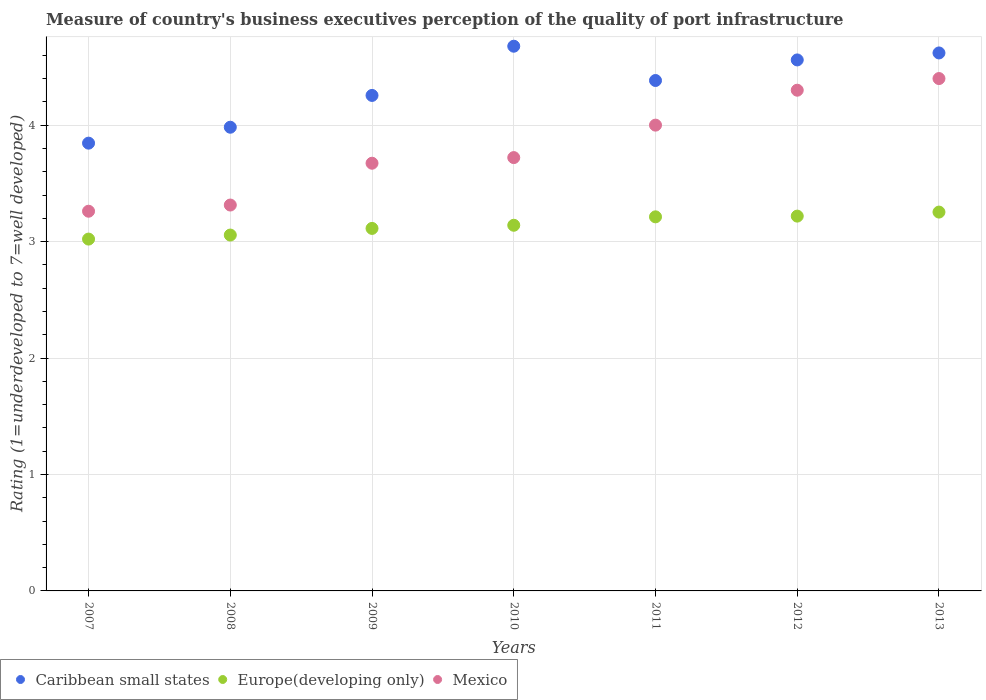Is the number of dotlines equal to the number of legend labels?
Offer a very short reply. Yes. What is the ratings of the quality of port infrastructure in Mexico in 2010?
Your response must be concise. 3.72. Across all years, what is the maximum ratings of the quality of port infrastructure in Europe(developing only)?
Your answer should be compact. 3.25. Across all years, what is the minimum ratings of the quality of port infrastructure in Mexico?
Your answer should be very brief. 3.26. In which year was the ratings of the quality of port infrastructure in Caribbean small states minimum?
Your answer should be compact. 2007. What is the total ratings of the quality of port infrastructure in Europe(developing only) in the graph?
Ensure brevity in your answer.  22.02. What is the difference between the ratings of the quality of port infrastructure in Europe(developing only) in 2007 and that in 2012?
Offer a very short reply. -0.2. What is the difference between the ratings of the quality of port infrastructure in Caribbean small states in 2008 and the ratings of the quality of port infrastructure in Europe(developing only) in 2007?
Provide a succinct answer. 0.96. What is the average ratings of the quality of port infrastructure in Mexico per year?
Offer a terse response. 3.81. In the year 2007, what is the difference between the ratings of the quality of port infrastructure in Caribbean small states and ratings of the quality of port infrastructure in Europe(developing only)?
Your answer should be compact. 0.82. In how many years, is the ratings of the quality of port infrastructure in Caribbean small states greater than 3.6?
Provide a short and direct response. 7. What is the ratio of the ratings of the quality of port infrastructure in Caribbean small states in 2011 to that in 2013?
Offer a very short reply. 0.95. What is the difference between the highest and the second highest ratings of the quality of port infrastructure in Mexico?
Offer a very short reply. 0.1. What is the difference between the highest and the lowest ratings of the quality of port infrastructure in Mexico?
Provide a succinct answer. 1.14. Does the ratings of the quality of port infrastructure in Mexico monotonically increase over the years?
Your answer should be compact. Yes. Are the values on the major ticks of Y-axis written in scientific E-notation?
Ensure brevity in your answer.  No. Does the graph contain any zero values?
Give a very brief answer. No. How are the legend labels stacked?
Give a very brief answer. Horizontal. What is the title of the graph?
Ensure brevity in your answer.  Measure of country's business executives perception of the quality of port infrastructure. What is the label or title of the X-axis?
Provide a short and direct response. Years. What is the label or title of the Y-axis?
Your answer should be compact. Rating (1=underdeveloped to 7=well developed). What is the Rating (1=underdeveloped to 7=well developed) in Caribbean small states in 2007?
Provide a succinct answer. 3.85. What is the Rating (1=underdeveloped to 7=well developed) in Europe(developing only) in 2007?
Provide a succinct answer. 3.02. What is the Rating (1=underdeveloped to 7=well developed) in Mexico in 2007?
Provide a succinct answer. 3.26. What is the Rating (1=underdeveloped to 7=well developed) in Caribbean small states in 2008?
Your response must be concise. 3.98. What is the Rating (1=underdeveloped to 7=well developed) in Europe(developing only) in 2008?
Your response must be concise. 3.06. What is the Rating (1=underdeveloped to 7=well developed) in Mexico in 2008?
Your answer should be very brief. 3.31. What is the Rating (1=underdeveloped to 7=well developed) in Caribbean small states in 2009?
Give a very brief answer. 4.26. What is the Rating (1=underdeveloped to 7=well developed) of Europe(developing only) in 2009?
Give a very brief answer. 3.11. What is the Rating (1=underdeveloped to 7=well developed) in Mexico in 2009?
Ensure brevity in your answer.  3.67. What is the Rating (1=underdeveloped to 7=well developed) of Caribbean small states in 2010?
Offer a very short reply. 4.68. What is the Rating (1=underdeveloped to 7=well developed) of Europe(developing only) in 2010?
Offer a terse response. 3.14. What is the Rating (1=underdeveloped to 7=well developed) of Mexico in 2010?
Provide a succinct answer. 3.72. What is the Rating (1=underdeveloped to 7=well developed) of Caribbean small states in 2011?
Ensure brevity in your answer.  4.38. What is the Rating (1=underdeveloped to 7=well developed) of Europe(developing only) in 2011?
Provide a succinct answer. 3.21. What is the Rating (1=underdeveloped to 7=well developed) in Mexico in 2011?
Ensure brevity in your answer.  4. What is the Rating (1=underdeveloped to 7=well developed) in Caribbean small states in 2012?
Give a very brief answer. 4.56. What is the Rating (1=underdeveloped to 7=well developed) in Europe(developing only) in 2012?
Offer a terse response. 3.22. What is the Rating (1=underdeveloped to 7=well developed) of Mexico in 2012?
Offer a very short reply. 4.3. What is the Rating (1=underdeveloped to 7=well developed) of Caribbean small states in 2013?
Offer a terse response. 4.62. What is the Rating (1=underdeveloped to 7=well developed) in Europe(developing only) in 2013?
Make the answer very short. 3.25. Across all years, what is the maximum Rating (1=underdeveloped to 7=well developed) in Caribbean small states?
Your response must be concise. 4.68. Across all years, what is the maximum Rating (1=underdeveloped to 7=well developed) in Europe(developing only)?
Offer a terse response. 3.25. Across all years, what is the maximum Rating (1=underdeveloped to 7=well developed) in Mexico?
Ensure brevity in your answer.  4.4. Across all years, what is the minimum Rating (1=underdeveloped to 7=well developed) in Caribbean small states?
Offer a terse response. 3.85. Across all years, what is the minimum Rating (1=underdeveloped to 7=well developed) of Europe(developing only)?
Your response must be concise. 3.02. Across all years, what is the minimum Rating (1=underdeveloped to 7=well developed) of Mexico?
Make the answer very short. 3.26. What is the total Rating (1=underdeveloped to 7=well developed) in Caribbean small states in the graph?
Your answer should be very brief. 30.32. What is the total Rating (1=underdeveloped to 7=well developed) in Europe(developing only) in the graph?
Your answer should be very brief. 22.02. What is the total Rating (1=underdeveloped to 7=well developed) in Mexico in the graph?
Your response must be concise. 26.67. What is the difference between the Rating (1=underdeveloped to 7=well developed) in Caribbean small states in 2007 and that in 2008?
Your response must be concise. -0.14. What is the difference between the Rating (1=underdeveloped to 7=well developed) in Europe(developing only) in 2007 and that in 2008?
Your answer should be compact. -0.03. What is the difference between the Rating (1=underdeveloped to 7=well developed) in Mexico in 2007 and that in 2008?
Keep it short and to the point. -0.05. What is the difference between the Rating (1=underdeveloped to 7=well developed) of Caribbean small states in 2007 and that in 2009?
Your answer should be very brief. -0.41. What is the difference between the Rating (1=underdeveloped to 7=well developed) in Europe(developing only) in 2007 and that in 2009?
Your answer should be very brief. -0.09. What is the difference between the Rating (1=underdeveloped to 7=well developed) of Mexico in 2007 and that in 2009?
Your answer should be compact. -0.41. What is the difference between the Rating (1=underdeveloped to 7=well developed) of Caribbean small states in 2007 and that in 2010?
Offer a terse response. -0.83. What is the difference between the Rating (1=underdeveloped to 7=well developed) of Europe(developing only) in 2007 and that in 2010?
Provide a succinct answer. -0.12. What is the difference between the Rating (1=underdeveloped to 7=well developed) of Mexico in 2007 and that in 2010?
Give a very brief answer. -0.46. What is the difference between the Rating (1=underdeveloped to 7=well developed) of Caribbean small states in 2007 and that in 2011?
Your answer should be compact. -0.54. What is the difference between the Rating (1=underdeveloped to 7=well developed) in Europe(developing only) in 2007 and that in 2011?
Provide a succinct answer. -0.19. What is the difference between the Rating (1=underdeveloped to 7=well developed) of Mexico in 2007 and that in 2011?
Make the answer very short. -0.74. What is the difference between the Rating (1=underdeveloped to 7=well developed) in Caribbean small states in 2007 and that in 2012?
Offer a very short reply. -0.71. What is the difference between the Rating (1=underdeveloped to 7=well developed) in Europe(developing only) in 2007 and that in 2012?
Give a very brief answer. -0.2. What is the difference between the Rating (1=underdeveloped to 7=well developed) in Mexico in 2007 and that in 2012?
Your answer should be compact. -1.04. What is the difference between the Rating (1=underdeveloped to 7=well developed) of Caribbean small states in 2007 and that in 2013?
Keep it short and to the point. -0.77. What is the difference between the Rating (1=underdeveloped to 7=well developed) of Europe(developing only) in 2007 and that in 2013?
Provide a succinct answer. -0.23. What is the difference between the Rating (1=underdeveloped to 7=well developed) of Mexico in 2007 and that in 2013?
Ensure brevity in your answer.  -1.14. What is the difference between the Rating (1=underdeveloped to 7=well developed) of Caribbean small states in 2008 and that in 2009?
Your response must be concise. -0.27. What is the difference between the Rating (1=underdeveloped to 7=well developed) in Europe(developing only) in 2008 and that in 2009?
Offer a terse response. -0.06. What is the difference between the Rating (1=underdeveloped to 7=well developed) of Mexico in 2008 and that in 2009?
Your response must be concise. -0.36. What is the difference between the Rating (1=underdeveloped to 7=well developed) in Caribbean small states in 2008 and that in 2010?
Provide a succinct answer. -0.7. What is the difference between the Rating (1=underdeveloped to 7=well developed) of Europe(developing only) in 2008 and that in 2010?
Provide a short and direct response. -0.08. What is the difference between the Rating (1=underdeveloped to 7=well developed) of Mexico in 2008 and that in 2010?
Ensure brevity in your answer.  -0.41. What is the difference between the Rating (1=underdeveloped to 7=well developed) of Caribbean small states in 2008 and that in 2011?
Give a very brief answer. -0.4. What is the difference between the Rating (1=underdeveloped to 7=well developed) of Europe(developing only) in 2008 and that in 2011?
Your answer should be compact. -0.16. What is the difference between the Rating (1=underdeveloped to 7=well developed) in Mexico in 2008 and that in 2011?
Your answer should be very brief. -0.69. What is the difference between the Rating (1=underdeveloped to 7=well developed) in Caribbean small states in 2008 and that in 2012?
Provide a succinct answer. -0.58. What is the difference between the Rating (1=underdeveloped to 7=well developed) in Europe(developing only) in 2008 and that in 2012?
Your response must be concise. -0.16. What is the difference between the Rating (1=underdeveloped to 7=well developed) of Mexico in 2008 and that in 2012?
Provide a short and direct response. -0.99. What is the difference between the Rating (1=underdeveloped to 7=well developed) in Caribbean small states in 2008 and that in 2013?
Provide a succinct answer. -0.64. What is the difference between the Rating (1=underdeveloped to 7=well developed) in Europe(developing only) in 2008 and that in 2013?
Your answer should be compact. -0.2. What is the difference between the Rating (1=underdeveloped to 7=well developed) of Mexico in 2008 and that in 2013?
Offer a very short reply. -1.09. What is the difference between the Rating (1=underdeveloped to 7=well developed) in Caribbean small states in 2009 and that in 2010?
Give a very brief answer. -0.42. What is the difference between the Rating (1=underdeveloped to 7=well developed) in Europe(developing only) in 2009 and that in 2010?
Offer a very short reply. -0.03. What is the difference between the Rating (1=underdeveloped to 7=well developed) of Mexico in 2009 and that in 2010?
Offer a very short reply. -0.05. What is the difference between the Rating (1=underdeveloped to 7=well developed) of Caribbean small states in 2009 and that in 2011?
Your answer should be very brief. -0.13. What is the difference between the Rating (1=underdeveloped to 7=well developed) of Europe(developing only) in 2009 and that in 2011?
Make the answer very short. -0.1. What is the difference between the Rating (1=underdeveloped to 7=well developed) in Mexico in 2009 and that in 2011?
Your answer should be compact. -0.33. What is the difference between the Rating (1=underdeveloped to 7=well developed) in Caribbean small states in 2009 and that in 2012?
Ensure brevity in your answer.  -0.3. What is the difference between the Rating (1=underdeveloped to 7=well developed) in Europe(developing only) in 2009 and that in 2012?
Keep it short and to the point. -0.11. What is the difference between the Rating (1=underdeveloped to 7=well developed) of Mexico in 2009 and that in 2012?
Ensure brevity in your answer.  -0.63. What is the difference between the Rating (1=underdeveloped to 7=well developed) in Caribbean small states in 2009 and that in 2013?
Offer a terse response. -0.36. What is the difference between the Rating (1=underdeveloped to 7=well developed) of Europe(developing only) in 2009 and that in 2013?
Ensure brevity in your answer.  -0.14. What is the difference between the Rating (1=underdeveloped to 7=well developed) of Mexico in 2009 and that in 2013?
Keep it short and to the point. -0.73. What is the difference between the Rating (1=underdeveloped to 7=well developed) of Caribbean small states in 2010 and that in 2011?
Your answer should be very brief. 0.29. What is the difference between the Rating (1=underdeveloped to 7=well developed) in Europe(developing only) in 2010 and that in 2011?
Make the answer very short. -0.07. What is the difference between the Rating (1=underdeveloped to 7=well developed) of Mexico in 2010 and that in 2011?
Offer a terse response. -0.28. What is the difference between the Rating (1=underdeveloped to 7=well developed) in Caribbean small states in 2010 and that in 2012?
Offer a terse response. 0.12. What is the difference between the Rating (1=underdeveloped to 7=well developed) of Europe(developing only) in 2010 and that in 2012?
Your answer should be very brief. -0.08. What is the difference between the Rating (1=underdeveloped to 7=well developed) in Mexico in 2010 and that in 2012?
Keep it short and to the point. -0.58. What is the difference between the Rating (1=underdeveloped to 7=well developed) of Caribbean small states in 2010 and that in 2013?
Your answer should be compact. 0.06. What is the difference between the Rating (1=underdeveloped to 7=well developed) in Europe(developing only) in 2010 and that in 2013?
Your answer should be very brief. -0.11. What is the difference between the Rating (1=underdeveloped to 7=well developed) in Mexico in 2010 and that in 2013?
Your answer should be compact. -0.68. What is the difference between the Rating (1=underdeveloped to 7=well developed) of Caribbean small states in 2011 and that in 2012?
Your answer should be compact. -0.18. What is the difference between the Rating (1=underdeveloped to 7=well developed) of Europe(developing only) in 2011 and that in 2012?
Give a very brief answer. -0.01. What is the difference between the Rating (1=underdeveloped to 7=well developed) of Mexico in 2011 and that in 2012?
Ensure brevity in your answer.  -0.3. What is the difference between the Rating (1=underdeveloped to 7=well developed) in Caribbean small states in 2011 and that in 2013?
Provide a short and direct response. -0.24. What is the difference between the Rating (1=underdeveloped to 7=well developed) in Europe(developing only) in 2011 and that in 2013?
Provide a succinct answer. -0.04. What is the difference between the Rating (1=underdeveloped to 7=well developed) in Caribbean small states in 2012 and that in 2013?
Ensure brevity in your answer.  -0.06. What is the difference between the Rating (1=underdeveloped to 7=well developed) of Europe(developing only) in 2012 and that in 2013?
Your answer should be very brief. -0.03. What is the difference between the Rating (1=underdeveloped to 7=well developed) of Caribbean small states in 2007 and the Rating (1=underdeveloped to 7=well developed) of Europe(developing only) in 2008?
Ensure brevity in your answer.  0.79. What is the difference between the Rating (1=underdeveloped to 7=well developed) in Caribbean small states in 2007 and the Rating (1=underdeveloped to 7=well developed) in Mexico in 2008?
Ensure brevity in your answer.  0.53. What is the difference between the Rating (1=underdeveloped to 7=well developed) of Europe(developing only) in 2007 and the Rating (1=underdeveloped to 7=well developed) of Mexico in 2008?
Provide a short and direct response. -0.29. What is the difference between the Rating (1=underdeveloped to 7=well developed) of Caribbean small states in 2007 and the Rating (1=underdeveloped to 7=well developed) of Europe(developing only) in 2009?
Keep it short and to the point. 0.73. What is the difference between the Rating (1=underdeveloped to 7=well developed) in Caribbean small states in 2007 and the Rating (1=underdeveloped to 7=well developed) in Mexico in 2009?
Keep it short and to the point. 0.17. What is the difference between the Rating (1=underdeveloped to 7=well developed) of Europe(developing only) in 2007 and the Rating (1=underdeveloped to 7=well developed) of Mexico in 2009?
Your response must be concise. -0.65. What is the difference between the Rating (1=underdeveloped to 7=well developed) of Caribbean small states in 2007 and the Rating (1=underdeveloped to 7=well developed) of Europe(developing only) in 2010?
Make the answer very short. 0.71. What is the difference between the Rating (1=underdeveloped to 7=well developed) of Caribbean small states in 2007 and the Rating (1=underdeveloped to 7=well developed) of Mexico in 2010?
Provide a short and direct response. 0.12. What is the difference between the Rating (1=underdeveloped to 7=well developed) in Europe(developing only) in 2007 and the Rating (1=underdeveloped to 7=well developed) in Mexico in 2010?
Offer a very short reply. -0.7. What is the difference between the Rating (1=underdeveloped to 7=well developed) of Caribbean small states in 2007 and the Rating (1=underdeveloped to 7=well developed) of Europe(developing only) in 2011?
Provide a succinct answer. 0.63. What is the difference between the Rating (1=underdeveloped to 7=well developed) in Caribbean small states in 2007 and the Rating (1=underdeveloped to 7=well developed) in Mexico in 2011?
Offer a very short reply. -0.15. What is the difference between the Rating (1=underdeveloped to 7=well developed) in Europe(developing only) in 2007 and the Rating (1=underdeveloped to 7=well developed) in Mexico in 2011?
Your response must be concise. -0.98. What is the difference between the Rating (1=underdeveloped to 7=well developed) in Caribbean small states in 2007 and the Rating (1=underdeveloped to 7=well developed) in Europe(developing only) in 2012?
Provide a succinct answer. 0.63. What is the difference between the Rating (1=underdeveloped to 7=well developed) in Caribbean small states in 2007 and the Rating (1=underdeveloped to 7=well developed) in Mexico in 2012?
Ensure brevity in your answer.  -0.45. What is the difference between the Rating (1=underdeveloped to 7=well developed) in Europe(developing only) in 2007 and the Rating (1=underdeveloped to 7=well developed) in Mexico in 2012?
Offer a very short reply. -1.28. What is the difference between the Rating (1=underdeveloped to 7=well developed) of Caribbean small states in 2007 and the Rating (1=underdeveloped to 7=well developed) of Europe(developing only) in 2013?
Provide a succinct answer. 0.59. What is the difference between the Rating (1=underdeveloped to 7=well developed) of Caribbean small states in 2007 and the Rating (1=underdeveloped to 7=well developed) of Mexico in 2013?
Keep it short and to the point. -0.55. What is the difference between the Rating (1=underdeveloped to 7=well developed) of Europe(developing only) in 2007 and the Rating (1=underdeveloped to 7=well developed) of Mexico in 2013?
Give a very brief answer. -1.38. What is the difference between the Rating (1=underdeveloped to 7=well developed) of Caribbean small states in 2008 and the Rating (1=underdeveloped to 7=well developed) of Europe(developing only) in 2009?
Make the answer very short. 0.87. What is the difference between the Rating (1=underdeveloped to 7=well developed) of Caribbean small states in 2008 and the Rating (1=underdeveloped to 7=well developed) of Mexico in 2009?
Provide a short and direct response. 0.31. What is the difference between the Rating (1=underdeveloped to 7=well developed) of Europe(developing only) in 2008 and the Rating (1=underdeveloped to 7=well developed) of Mexico in 2009?
Your answer should be very brief. -0.62. What is the difference between the Rating (1=underdeveloped to 7=well developed) in Caribbean small states in 2008 and the Rating (1=underdeveloped to 7=well developed) in Europe(developing only) in 2010?
Keep it short and to the point. 0.84. What is the difference between the Rating (1=underdeveloped to 7=well developed) in Caribbean small states in 2008 and the Rating (1=underdeveloped to 7=well developed) in Mexico in 2010?
Provide a succinct answer. 0.26. What is the difference between the Rating (1=underdeveloped to 7=well developed) of Europe(developing only) in 2008 and the Rating (1=underdeveloped to 7=well developed) of Mexico in 2010?
Provide a short and direct response. -0.67. What is the difference between the Rating (1=underdeveloped to 7=well developed) of Caribbean small states in 2008 and the Rating (1=underdeveloped to 7=well developed) of Europe(developing only) in 2011?
Make the answer very short. 0.77. What is the difference between the Rating (1=underdeveloped to 7=well developed) of Caribbean small states in 2008 and the Rating (1=underdeveloped to 7=well developed) of Mexico in 2011?
Ensure brevity in your answer.  -0.02. What is the difference between the Rating (1=underdeveloped to 7=well developed) in Europe(developing only) in 2008 and the Rating (1=underdeveloped to 7=well developed) in Mexico in 2011?
Ensure brevity in your answer.  -0.94. What is the difference between the Rating (1=underdeveloped to 7=well developed) of Caribbean small states in 2008 and the Rating (1=underdeveloped to 7=well developed) of Europe(developing only) in 2012?
Keep it short and to the point. 0.76. What is the difference between the Rating (1=underdeveloped to 7=well developed) of Caribbean small states in 2008 and the Rating (1=underdeveloped to 7=well developed) of Mexico in 2012?
Provide a short and direct response. -0.32. What is the difference between the Rating (1=underdeveloped to 7=well developed) in Europe(developing only) in 2008 and the Rating (1=underdeveloped to 7=well developed) in Mexico in 2012?
Your answer should be very brief. -1.24. What is the difference between the Rating (1=underdeveloped to 7=well developed) of Caribbean small states in 2008 and the Rating (1=underdeveloped to 7=well developed) of Europe(developing only) in 2013?
Provide a succinct answer. 0.73. What is the difference between the Rating (1=underdeveloped to 7=well developed) of Caribbean small states in 2008 and the Rating (1=underdeveloped to 7=well developed) of Mexico in 2013?
Make the answer very short. -0.42. What is the difference between the Rating (1=underdeveloped to 7=well developed) in Europe(developing only) in 2008 and the Rating (1=underdeveloped to 7=well developed) in Mexico in 2013?
Make the answer very short. -1.34. What is the difference between the Rating (1=underdeveloped to 7=well developed) in Caribbean small states in 2009 and the Rating (1=underdeveloped to 7=well developed) in Europe(developing only) in 2010?
Provide a succinct answer. 1.11. What is the difference between the Rating (1=underdeveloped to 7=well developed) of Caribbean small states in 2009 and the Rating (1=underdeveloped to 7=well developed) of Mexico in 2010?
Your answer should be compact. 0.53. What is the difference between the Rating (1=underdeveloped to 7=well developed) of Europe(developing only) in 2009 and the Rating (1=underdeveloped to 7=well developed) of Mexico in 2010?
Your response must be concise. -0.61. What is the difference between the Rating (1=underdeveloped to 7=well developed) of Caribbean small states in 2009 and the Rating (1=underdeveloped to 7=well developed) of Europe(developing only) in 2011?
Your answer should be compact. 1.04. What is the difference between the Rating (1=underdeveloped to 7=well developed) in Caribbean small states in 2009 and the Rating (1=underdeveloped to 7=well developed) in Mexico in 2011?
Keep it short and to the point. 0.26. What is the difference between the Rating (1=underdeveloped to 7=well developed) in Europe(developing only) in 2009 and the Rating (1=underdeveloped to 7=well developed) in Mexico in 2011?
Keep it short and to the point. -0.89. What is the difference between the Rating (1=underdeveloped to 7=well developed) in Caribbean small states in 2009 and the Rating (1=underdeveloped to 7=well developed) in Europe(developing only) in 2012?
Ensure brevity in your answer.  1.04. What is the difference between the Rating (1=underdeveloped to 7=well developed) of Caribbean small states in 2009 and the Rating (1=underdeveloped to 7=well developed) of Mexico in 2012?
Ensure brevity in your answer.  -0.04. What is the difference between the Rating (1=underdeveloped to 7=well developed) of Europe(developing only) in 2009 and the Rating (1=underdeveloped to 7=well developed) of Mexico in 2012?
Make the answer very short. -1.19. What is the difference between the Rating (1=underdeveloped to 7=well developed) in Caribbean small states in 2009 and the Rating (1=underdeveloped to 7=well developed) in Europe(developing only) in 2013?
Offer a terse response. 1. What is the difference between the Rating (1=underdeveloped to 7=well developed) in Caribbean small states in 2009 and the Rating (1=underdeveloped to 7=well developed) in Mexico in 2013?
Make the answer very short. -0.14. What is the difference between the Rating (1=underdeveloped to 7=well developed) in Europe(developing only) in 2009 and the Rating (1=underdeveloped to 7=well developed) in Mexico in 2013?
Provide a succinct answer. -1.29. What is the difference between the Rating (1=underdeveloped to 7=well developed) of Caribbean small states in 2010 and the Rating (1=underdeveloped to 7=well developed) of Europe(developing only) in 2011?
Offer a terse response. 1.47. What is the difference between the Rating (1=underdeveloped to 7=well developed) in Caribbean small states in 2010 and the Rating (1=underdeveloped to 7=well developed) in Mexico in 2011?
Keep it short and to the point. 0.68. What is the difference between the Rating (1=underdeveloped to 7=well developed) of Europe(developing only) in 2010 and the Rating (1=underdeveloped to 7=well developed) of Mexico in 2011?
Keep it short and to the point. -0.86. What is the difference between the Rating (1=underdeveloped to 7=well developed) of Caribbean small states in 2010 and the Rating (1=underdeveloped to 7=well developed) of Europe(developing only) in 2012?
Offer a terse response. 1.46. What is the difference between the Rating (1=underdeveloped to 7=well developed) of Caribbean small states in 2010 and the Rating (1=underdeveloped to 7=well developed) of Mexico in 2012?
Your answer should be very brief. 0.38. What is the difference between the Rating (1=underdeveloped to 7=well developed) in Europe(developing only) in 2010 and the Rating (1=underdeveloped to 7=well developed) in Mexico in 2012?
Make the answer very short. -1.16. What is the difference between the Rating (1=underdeveloped to 7=well developed) of Caribbean small states in 2010 and the Rating (1=underdeveloped to 7=well developed) of Europe(developing only) in 2013?
Offer a very short reply. 1.42. What is the difference between the Rating (1=underdeveloped to 7=well developed) of Caribbean small states in 2010 and the Rating (1=underdeveloped to 7=well developed) of Mexico in 2013?
Provide a succinct answer. 0.28. What is the difference between the Rating (1=underdeveloped to 7=well developed) in Europe(developing only) in 2010 and the Rating (1=underdeveloped to 7=well developed) in Mexico in 2013?
Offer a terse response. -1.26. What is the difference between the Rating (1=underdeveloped to 7=well developed) in Caribbean small states in 2011 and the Rating (1=underdeveloped to 7=well developed) in Europe(developing only) in 2012?
Your answer should be compact. 1.16. What is the difference between the Rating (1=underdeveloped to 7=well developed) in Caribbean small states in 2011 and the Rating (1=underdeveloped to 7=well developed) in Mexico in 2012?
Provide a short and direct response. 0.08. What is the difference between the Rating (1=underdeveloped to 7=well developed) of Europe(developing only) in 2011 and the Rating (1=underdeveloped to 7=well developed) of Mexico in 2012?
Provide a succinct answer. -1.09. What is the difference between the Rating (1=underdeveloped to 7=well developed) of Caribbean small states in 2011 and the Rating (1=underdeveloped to 7=well developed) of Europe(developing only) in 2013?
Offer a very short reply. 1.13. What is the difference between the Rating (1=underdeveloped to 7=well developed) of Caribbean small states in 2011 and the Rating (1=underdeveloped to 7=well developed) of Mexico in 2013?
Give a very brief answer. -0.02. What is the difference between the Rating (1=underdeveloped to 7=well developed) of Europe(developing only) in 2011 and the Rating (1=underdeveloped to 7=well developed) of Mexico in 2013?
Ensure brevity in your answer.  -1.19. What is the difference between the Rating (1=underdeveloped to 7=well developed) of Caribbean small states in 2012 and the Rating (1=underdeveloped to 7=well developed) of Europe(developing only) in 2013?
Offer a very short reply. 1.31. What is the difference between the Rating (1=underdeveloped to 7=well developed) of Caribbean small states in 2012 and the Rating (1=underdeveloped to 7=well developed) of Mexico in 2013?
Your answer should be compact. 0.16. What is the difference between the Rating (1=underdeveloped to 7=well developed) of Europe(developing only) in 2012 and the Rating (1=underdeveloped to 7=well developed) of Mexico in 2013?
Your response must be concise. -1.18. What is the average Rating (1=underdeveloped to 7=well developed) of Caribbean small states per year?
Make the answer very short. 4.33. What is the average Rating (1=underdeveloped to 7=well developed) of Europe(developing only) per year?
Offer a very short reply. 3.15. What is the average Rating (1=underdeveloped to 7=well developed) in Mexico per year?
Offer a terse response. 3.81. In the year 2007, what is the difference between the Rating (1=underdeveloped to 7=well developed) of Caribbean small states and Rating (1=underdeveloped to 7=well developed) of Europe(developing only)?
Provide a short and direct response. 0.82. In the year 2007, what is the difference between the Rating (1=underdeveloped to 7=well developed) in Caribbean small states and Rating (1=underdeveloped to 7=well developed) in Mexico?
Your answer should be compact. 0.58. In the year 2007, what is the difference between the Rating (1=underdeveloped to 7=well developed) of Europe(developing only) and Rating (1=underdeveloped to 7=well developed) of Mexico?
Give a very brief answer. -0.24. In the year 2008, what is the difference between the Rating (1=underdeveloped to 7=well developed) in Caribbean small states and Rating (1=underdeveloped to 7=well developed) in Europe(developing only)?
Give a very brief answer. 0.93. In the year 2008, what is the difference between the Rating (1=underdeveloped to 7=well developed) of Caribbean small states and Rating (1=underdeveloped to 7=well developed) of Mexico?
Your answer should be very brief. 0.67. In the year 2008, what is the difference between the Rating (1=underdeveloped to 7=well developed) of Europe(developing only) and Rating (1=underdeveloped to 7=well developed) of Mexico?
Your answer should be very brief. -0.26. In the year 2009, what is the difference between the Rating (1=underdeveloped to 7=well developed) of Caribbean small states and Rating (1=underdeveloped to 7=well developed) of Europe(developing only)?
Ensure brevity in your answer.  1.14. In the year 2009, what is the difference between the Rating (1=underdeveloped to 7=well developed) of Caribbean small states and Rating (1=underdeveloped to 7=well developed) of Mexico?
Make the answer very short. 0.58. In the year 2009, what is the difference between the Rating (1=underdeveloped to 7=well developed) of Europe(developing only) and Rating (1=underdeveloped to 7=well developed) of Mexico?
Make the answer very short. -0.56. In the year 2010, what is the difference between the Rating (1=underdeveloped to 7=well developed) of Caribbean small states and Rating (1=underdeveloped to 7=well developed) of Europe(developing only)?
Your answer should be very brief. 1.54. In the year 2010, what is the difference between the Rating (1=underdeveloped to 7=well developed) of Caribbean small states and Rating (1=underdeveloped to 7=well developed) of Mexico?
Your answer should be compact. 0.96. In the year 2010, what is the difference between the Rating (1=underdeveloped to 7=well developed) of Europe(developing only) and Rating (1=underdeveloped to 7=well developed) of Mexico?
Your answer should be very brief. -0.58. In the year 2011, what is the difference between the Rating (1=underdeveloped to 7=well developed) of Caribbean small states and Rating (1=underdeveloped to 7=well developed) of Europe(developing only)?
Make the answer very short. 1.17. In the year 2011, what is the difference between the Rating (1=underdeveloped to 7=well developed) in Caribbean small states and Rating (1=underdeveloped to 7=well developed) in Mexico?
Make the answer very short. 0.38. In the year 2011, what is the difference between the Rating (1=underdeveloped to 7=well developed) in Europe(developing only) and Rating (1=underdeveloped to 7=well developed) in Mexico?
Your answer should be compact. -0.79. In the year 2012, what is the difference between the Rating (1=underdeveloped to 7=well developed) of Caribbean small states and Rating (1=underdeveloped to 7=well developed) of Europe(developing only)?
Your answer should be very brief. 1.34. In the year 2012, what is the difference between the Rating (1=underdeveloped to 7=well developed) of Caribbean small states and Rating (1=underdeveloped to 7=well developed) of Mexico?
Your response must be concise. 0.26. In the year 2012, what is the difference between the Rating (1=underdeveloped to 7=well developed) in Europe(developing only) and Rating (1=underdeveloped to 7=well developed) in Mexico?
Keep it short and to the point. -1.08. In the year 2013, what is the difference between the Rating (1=underdeveloped to 7=well developed) in Caribbean small states and Rating (1=underdeveloped to 7=well developed) in Europe(developing only)?
Make the answer very short. 1.37. In the year 2013, what is the difference between the Rating (1=underdeveloped to 7=well developed) of Caribbean small states and Rating (1=underdeveloped to 7=well developed) of Mexico?
Your answer should be compact. 0.22. In the year 2013, what is the difference between the Rating (1=underdeveloped to 7=well developed) in Europe(developing only) and Rating (1=underdeveloped to 7=well developed) in Mexico?
Provide a short and direct response. -1.15. What is the ratio of the Rating (1=underdeveloped to 7=well developed) of Caribbean small states in 2007 to that in 2008?
Your answer should be compact. 0.97. What is the ratio of the Rating (1=underdeveloped to 7=well developed) of Europe(developing only) in 2007 to that in 2008?
Your response must be concise. 0.99. What is the ratio of the Rating (1=underdeveloped to 7=well developed) in Caribbean small states in 2007 to that in 2009?
Your response must be concise. 0.9. What is the ratio of the Rating (1=underdeveloped to 7=well developed) in Europe(developing only) in 2007 to that in 2009?
Keep it short and to the point. 0.97. What is the ratio of the Rating (1=underdeveloped to 7=well developed) in Mexico in 2007 to that in 2009?
Make the answer very short. 0.89. What is the ratio of the Rating (1=underdeveloped to 7=well developed) of Caribbean small states in 2007 to that in 2010?
Ensure brevity in your answer.  0.82. What is the ratio of the Rating (1=underdeveloped to 7=well developed) of Europe(developing only) in 2007 to that in 2010?
Your response must be concise. 0.96. What is the ratio of the Rating (1=underdeveloped to 7=well developed) in Mexico in 2007 to that in 2010?
Make the answer very short. 0.88. What is the ratio of the Rating (1=underdeveloped to 7=well developed) of Caribbean small states in 2007 to that in 2011?
Give a very brief answer. 0.88. What is the ratio of the Rating (1=underdeveloped to 7=well developed) of Europe(developing only) in 2007 to that in 2011?
Keep it short and to the point. 0.94. What is the ratio of the Rating (1=underdeveloped to 7=well developed) in Mexico in 2007 to that in 2011?
Your answer should be compact. 0.82. What is the ratio of the Rating (1=underdeveloped to 7=well developed) in Caribbean small states in 2007 to that in 2012?
Ensure brevity in your answer.  0.84. What is the ratio of the Rating (1=underdeveloped to 7=well developed) in Europe(developing only) in 2007 to that in 2012?
Give a very brief answer. 0.94. What is the ratio of the Rating (1=underdeveloped to 7=well developed) of Mexico in 2007 to that in 2012?
Give a very brief answer. 0.76. What is the ratio of the Rating (1=underdeveloped to 7=well developed) of Caribbean small states in 2007 to that in 2013?
Offer a terse response. 0.83. What is the ratio of the Rating (1=underdeveloped to 7=well developed) of Europe(developing only) in 2007 to that in 2013?
Give a very brief answer. 0.93. What is the ratio of the Rating (1=underdeveloped to 7=well developed) in Mexico in 2007 to that in 2013?
Keep it short and to the point. 0.74. What is the ratio of the Rating (1=underdeveloped to 7=well developed) of Caribbean small states in 2008 to that in 2009?
Offer a terse response. 0.94. What is the ratio of the Rating (1=underdeveloped to 7=well developed) of Europe(developing only) in 2008 to that in 2009?
Ensure brevity in your answer.  0.98. What is the ratio of the Rating (1=underdeveloped to 7=well developed) of Mexico in 2008 to that in 2009?
Provide a succinct answer. 0.9. What is the ratio of the Rating (1=underdeveloped to 7=well developed) in Caribbean small states in 2008 to that in 2010?
Give a very brief answer. 0.85. What is the ratio of the Rating (1=underdeveloped to 7=well developed) in Europe(developing only) in 2008 to that in 2010?
Offer a terse response. 0.97. What is the ratio of the Rating (1=underdeveloped to 7=well developed) of Mexico in 2008 to that in 2010?
Provide a succinct answer. 0.89. What is the ratio of the Rating (1=underdeveloped to 7=well developed) in Caribbean small states in 2008 to that in 2011?
Provide a succinct answer. 0.91. What is the ratio of the Rating (1=underdeveloped to 7=well developed) of Europe(developing only) in 2008 to that in 2011?
Offer a very short reply. 0.95. What is the ratio of the Rating (1=underdeveloped to 7=well developed) of Mexico in 2008 to that in 2011?
Ensure brevity in your answer.  0.83. What is the ratio of the Rating (1=underdeveloped to 7=well developed) of Caribbean small states in 2008 to that in 2012?
Ensure brevity in your answer.  0.87. What is the ratio of the Rating (1=underdeveloped to 7=well developed) in Europe(developing only) in 2008 to that in 2012?
Make the answer very short. 0.95. What is the ratio of the Rating (1=underdeveloped to 7=well developed) of Mexico in 2008 to that in 2012?
Provide a short and direct response. 0.77. What is the ratio of the Rating (1=underdeveloped to 7=well developed) in Caribbean small states in 2008 to that in 2013?
Offer a terse response. 0.86. What is the ratio of the Rating (1=underdeveloped to 7=well developed) of Europe(developing only) in 2008 to that in 2013?
Give a very brief answer. 0.94. What is the ratio of the Rating (1=underdeveloped to 7=well developed) of Mexico in 2008 to that in 2013?
Your answer should be very brief. 0.75. What is the ratio of the Rating (1=underdeveloped to 7=well developed) of Caribbean small states in 2009 to that in 2010?
Your answer should be very brief. 0.91. What is the ratio of the Rating (1=underdeveloped to 7=well developed) in Europe(developing only) in 2009 to that in 2010?
Offer a very short reply. 0.99. What is the ratio of the Rating (1=underdeveloped to 7=well developed) of Mexico in 2009 to that in 2010?
Provide a short and direct response. 0.99. What is the ratio of the Rating (1=underdeveloped to 7=well developed) of Caribbean small states in 2009 to that in 2011?
Provide a short and direct response. 0.97. What is the ratio of the Rating (1=underdeveloped to 7=well developed) in Europe(developing only) in 2009 to that in 2011?
Your response must be concise. 0.97. What is the ratio of the Rating (1=underdeveloped to 7=well developed) of Mexico in 2009 to that in 2011?
Make the answer very short. 0.92. What is the ratio of the Rating (1=underdeveloped to 7=well developed) in Caribbean small states in 2009 to that in 2012?
Make the answer very short. 0.93. What is the ratio of the Rating (1=underdeveloped to 7=well developed) of Europe(developing only) in 2009 to that in 2012?
Offer a terse response. 0.97. What is the ratio of the Rating (1=underdeveloped to 7=well developed) in Mexico in 2009 to that in 2012?
Offer a terse response. 0.85. What is the ratio of the Rating (1=underdeveloped to 7=well developed) of Caribbean small states in 2009 to that in 2013?
Offer a very short reply. 0.92. What is the ratio of the Rating (1=underdeveloped to 7=well developed) of Europe(developing only) in 2009 to that in 2013?
Your answer should be compact. 0.96. What is the ratio of the Rating (1=underdeveloped to 7=well developed) of Mexico in 2009 to that in 2013?
Give a very brief answer. 0.83. What is the ratio of the Rating (1=underdeveloped to 7=well developed) of Caribbean small states in 2010 to that in 2011?
Provide a short and direct response. 1.07. What is the ratio of the Rating (1=underdeveloped to 7=well developed) of Europe(developing only) in 2010 to that in 2011?
Keep it short and to the point. 0.98. What is the ratio of the Rating (1=underdeveloped to 7=well developed) in Mexico in 2010 to that in 2011?
Make the answer very short. 0.93. What is the ratio of the Rating (1=underdeveloped to 7=well developed) of Caribbean small states in 2010 to that in 2012?
Offer a terse response. 1.03. What is the ratio of the Rating (1=underdeveloped to 7=well developed) of Europe(developing only) in 2010 to that in 2012?
Make the answer very short. 0.98. What is the ratio of the Rating (1=underdeveloped to 7=well developed) of Mexico in 2010 to that in 2012?
Offer a very short reply. 0.87. What is the ratio of the Rating (1=underdeveloped to 7=well developed) in Caribbean small states in 2010 to that in 2013?
Give a very brief answer. 1.01. What is the ratio of the Rating (1=underdeveloped to 7=well developed) in Europe(developing only) in 2010 to that in 2013?
Offer a very short reply. 0.97. What is the ratio of the Rating (1=underdeveloped to 7=well developed) of Mexico in 2010 to that in 2013?
Provide a succinct answer. 0.85. What is the ratio of the Rating (1=underdeveloped to 7=well developed) in Caribbean small states in 2011 to that in 2012?
Keep it short and to the point. 0.96. What is the ratio of the Rating (1=underdeveloped to 7=well developed) of Europe(developing only) in 2011 to that in 2012?
Your answer should be compact. 1. What is the ratio of the Rating (1=underdeveloped to 7=well developed) of Mexico in 2011 to that in 2012?
Your answer should be compact. 0.93. What is the ratio of the Rating (1=underdeveloped to 7=well developed) in Caribbean small states in 2011 to that in 2013?
Ensure brevity in your answer.  0.95. What is the ratio of the Rating (1=underdeveloped to 7=well developed) of Europe(developing only) in 2011 to that in 2013?
Your response must be concise. 0.99. What is the ratio of the Rating (1=underdeveloped to 7=well developed) of Caribbean small states in 2012 to that in 2013?
Your answer should be very brief. 0.99. What is the ratio of the Rating (1=underdeveloped to 7=well developed) in Europe(developing only) in 2012 to that in 2013?
Your answer should be very brief. 0.99. What is the ratio of the Rating (1=underdeveloped to 7=well developed) in Mexico in 2012 to that in 2013?
Keep it short and to the point. 0.98. What is the difference between the highest and the second highest Rating (1=underdeveloped to 7=well developed) in Caribbean small states?
Keep it short and to the point. 0.06. What is the difference between the highest and the second highest Rating (1=underdeveloped to 7=well developed) of Europe(developing only)?
Offer a very short reply. 0.03. What is the difference between the highest and the second highest Rating (1=underdeveloped to 7=well developed) in Mexico?
Your answer should be very brief. 0.1. What is the difference between the highest and the lowest Rating (1=underdeveloped to 7=well developed) in Caribbean small states?
Provide a succinct answer. 0.83. What is the difference between the highest and the lowest Rating (1=underdeveloped to 7=well developed) of Europe(developing only)?
Ensure brevity in your answer.  0.23. What is the difference between the highest and the lowest Rating (1=underdeveloped to 7=well developed) in Mexico?
Keep it short and to the point. 1.14. 